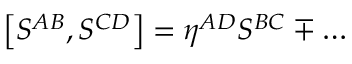Convert formula to latex. <formula><loc_0><loc_0><loc_500><loc_500>\left [ S ^ { A B } , S ^ { C D } \right ] = \eta ^ { A D } S ^ { B C } \mp \dots</formula> 